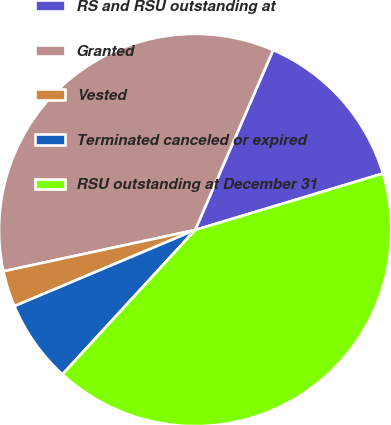<chart> <loc_0><loc_0><loc_500><loc_500><pie_chart><fcel>RS and RSU outstanding at<fcel>Granted<fcel>Vested<fcel>Terminated canceled or expired<fcel>RSU outstanding at December 31<nl><fcel>13.84%<fcel>34.88%<fcel>2.97%<fcel>6.82%<fcel>41.48%<nl></chart> 